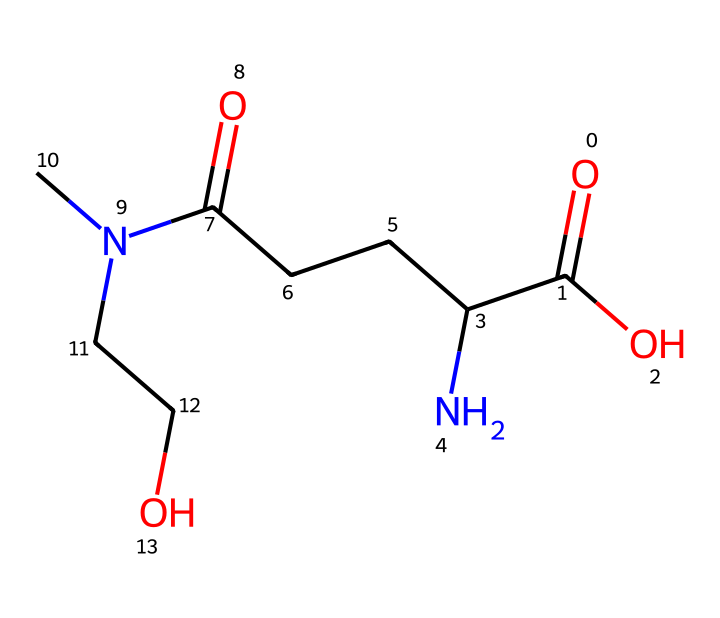What is the molecular formula of L-theanine? The SMILES representation can be analyzed to count the number of each type of atom. From the structure, we can identify that there are 8 carbon atoms, 16 hydrogen atoms, 3 nitrogen atoms, and 3 oxygen atoms, giving a molecular formula of C8H16N2O3.
Answer: C8H16N2O3 How many chiral centers are present in the structure? To identify chiral centers, we look for carbon atoms bonded to four different groups. In the given SMILES, there is one carbon that meets this criterion, indicating one chiral center in L-theanine.
Answer: 1 What functional groups are present in L-theanine? By examining the structure, we can identify key functional groups: a carboxylic acid (-COOH), an amine (-NH), and a hydroxyl group (-OH). Each of these influences the behavior of L-theanine in solution.
Answer: carboxylic acid, amine, hydroxyl What type of interactions can L-theanine form due to its functional groups? The presence of the polar functional groups allows L-theanine to engage in hydrogen bonding. This means it can interact well with water and other polar solvents, influencing its solubility and biological activity.
Answer: hydrogen bonding What is the primary source of L-theanine? The SMILES structure depicts L-theanine's presence in tea, specifically in green tea leaves. This indicates that the compound is naturally derived from this plant source, widely consumed as a beverage.
Answer: tea How might the structure relate to L-theanine's effect on stress? The combination of the amino acid and the presence of functional groups likely contributes to neuroactive properties, which may modulate stress levels. The structural components work collectively to enhance focus and relaxation, which is beneficial for stress relief.
Answer: neuroactive properties 